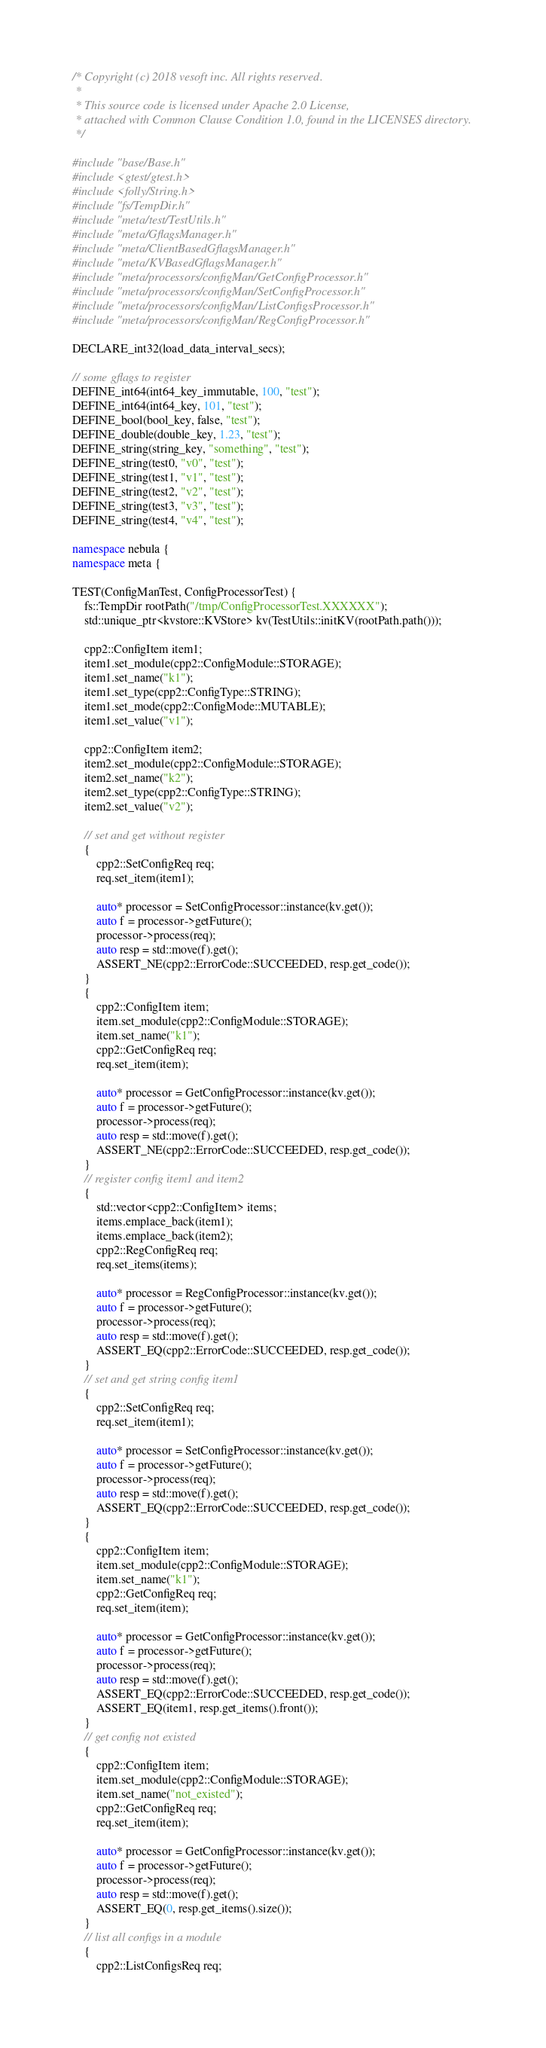Convert code to text. <code><loc_0><loc_0><loc_500><loc_500><_C++_>/* Copyright (c) 2018 vesoft inc. All rights reserved.
 *
 * This source code is licensed under Apache 2.0 License,
 * attached with Common Clause Condition 1.0, found in the LICENSES directory.
 */

#include "base/Base.h"
#include <gtest/gtest.h>
#include <folly/String.h>
#include "fs/TempDir.h"
#include "meta/test/TestUtils.h"
#include "meta/GflagsManager.h"
#include "meta/ClientBasedGflagsManager.h"
#include "meta/KVBasedGflagsManager.h"
#include "meta/processors/configMan/GetConfigProcessor.h"
#include "meta/processors/configMan/SetConfigProcessor.h"
#include "meta/processors/configMan/ListConfigsProcessor.h"
#include "meta/processors/configMan/RegConfigProcessor.h"

DECLARE_int32(load_data_interval_secs);

// some gflags to register
DEFINE_int64(int64_key_immutable, 100, "test");
DEFINE_int64(int64_key, 101, "test");
DEFINE_bool(bool_key, false, "test");
DEFINE_double(double_key, 1.23, "test");
DEFINE_string(string_key, "something", "test");
DEFINE_string(test0, "v0", "test");
DEFINE_string(test1, "v1", "test");
DEFINE_string(test2, "v2", "test");
DEFINE_string(test3, "v3", "test");
DEFINE_string(test4, "v4", "test");

namespace nebula {
namespace meta {

TEST(ConfigManTest, ConfigProcessorTest) {
    fs::TempDir rootPath("/tmp/ConfigProcessorTest.XXXXXX");
    std::unique_ptr<kvstore::KVStore> kv(TestUtils::initKV(rootPath.path()));

    cpp2::ConfigItem item1;
    item1.set_module(cpp2::ConfigModule::STORAGE);
    item1.set_name("k1");
    item1.set_type(cpp2::ConfigType::STRING);
    item1.set_mode(cpp2::ConfigMode::MUTABLE);
    item1.set_value("v1");

    cpp2::ConfigItem item2;
    item2.set_module(cpp2::ConfigModule::STORAGE);
    item2.set_name("k2");
    item2.set_type(cpp2::ConfigType::STRING);
    item2.set_value("v2");

    // set and get without register
    {
        cpp2::SetConfigReq req;
        req.set_item(item1);

        auto* processor = SetConfigProcessor::instance(kv.get());
        auto f = processor->getFuture();
        processor->process(req);
        auto resp = std::move(f).get();
        ASSERT_NE(cpp2::ErrorCode::SUCCEEDED, resp.get_code());
    }
    {
        cpp2::ConfigItem item;
        item.set_module(cpp2::ConfigModule::STORAGE);
        item.set_name("k1");
        cpp2::GetConfigReq req;
        req.set_item(item);

        auto* processor = GetConfigProcessor::instance(kv.get());
        auto f = processor->getFuture();
        processor->process(req);
        auto resp = std::move(f).get();
        ASSERT_NE(cpp2::ErrorCode::SUCCEEDED, resp.get_code());
    }
    // register config item1 and item2
    {
        std::vector<cpp2::ConfigItem> items;
        items.emplace_back(item1);
        items.emplace_back(item2);
        cpp2::RegConfigReq req;
        req.set_items(items);

        auto* processor = RegConfigProcessor::instance(kv.get());
        auto f = processor->getFuture();
        processor->process(req);
        auto resp = std::move(f).get();
        ASSERT_EQ(cpp2::ErrorCode::SUCCEEDED, resp.get_code());
    }
    // set and get string config item1
    {
        cpp2::SetConfigReq req;
        req.set_item(item1);

        auto* processor = SetConfigProcessor::instance(kv.get());
        auto f = processor->getFuture();
        processor->process(req);
        auto resp = std::move(f).get();
        ASSERT_EQ(cpp2::ErrorCode::SUCCEEDED, resp.get_code());
    }
    {
        cpp2::ConfigItem item;
        item.set_module(cpp2::ConfigModule::STORAGE);
        item.set_name("k1");
        cpp2::GetConfigReq req;
        req.set_item(item);

        auto* processor = GetConfigProcessor::instance(kv.get());
        auto f = processor->getFuture();
        processor->process(req);
        auto resp = std::move(f).get();
        ASSERT_EQ(cpp2::ErrorCode::SUCCEEDED, resp.get_code());
        ASSERT_EQ(item1, resp.get_items().front());
    }
    // get config not existed
    {
        cpp2::ConfigItem item;
        item.set_module(cpp2::ConfigModule::STORAGE);
        item.set_name("not_existed");
        cpp2::GetConfigReq req;
        req.set_item(item);

        auto* processor = GetConfigProcessor::instance(kv.get());
        auto f = processor->getFuture();
        processor->process(req);
        auto resp = std::move(f).get();
        ASSERT_EQ(0, resp.get_items().size());
    }
    // list all configs in a module
    {
        cpp2::ListConfigsReq req;</code> 